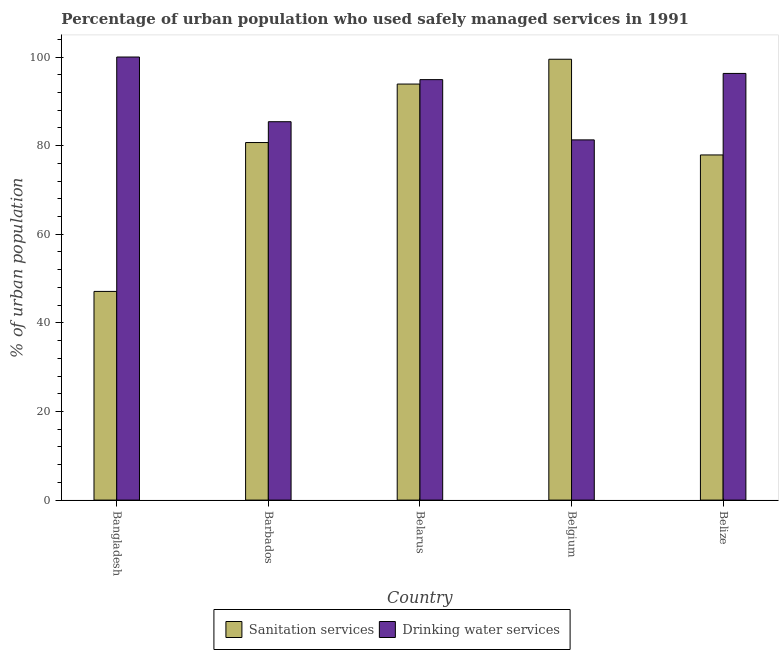How many bars are there on the 4th tick from the right?
Keep it short and to the point. 2. What is the label of the 3rd group of bars from the left?
Provide a succinct answer. Belarus. In how many cases, is the number of bars for a given country not equal to the number of legend labels?
Provide a succinct answer. 0. What is the percentage of urban population who used sanitation services in Belize?
Offer a terse response. 77.9. Across all countries, what is the minimum percentage of urban population who used drinking water services?
Keep it short and to the point. 81.3. In which country was the percentage of urban population who used drinking water services maximum?
Your response must be concise. Bangladesh. In which country was the percentage of urban population who used drinking water services minimum?
Provide a short and direct response. Belgium. What is the total percentage of urban population who used drinking water services in the graph?
Your answer should be compact. 457.9. What is the difference between the percentage of urban population who used sanitation services in Belgium and that in Belize?
Offer a very short reply. 21.6. What is the difference between the percentage of urban population who used drinking water services in Belgium and the percentage of urban population who used sanitation services in Barbados?
Your answer should be compact. 0.6. What is the average percentage of urban population who used drinking water services per country?
Ensure brevity in your answer.  91.58. What is the difference between the percentage of urban population who used sanitation services and percentage of urban population who used drinking water services in Barbados?
Your answer should be compact. -4.7. What is the ratio of the percentage of urban population who used drinking water services in Barbados to that in Belgium?
Your answer should be compact. 1.05. Is the percentage of urban population who used sanitation services in Barbados less than that in Belgium?
Offer a very short reply. Yes. Is the difference between the percentage of urban population who used drinking water services in Bangladesh and Belgium greater than the difference between the percentage of urban population who used sanitation services in Bangladesh and Belgium?
Ensure brevity in your answer.  Yes. What is the difference between the highest and the second highest percentage of urban population who used drinking water services?
Provide a short and direct response. 3.7. What is the difference between the highest and the lowest percentage of urban population who used sanitation services?
Offer a terse response. 52.4. In how many countries, is the percentage of urban population who used sanitation services greater than the average percentage of urban population who used sanitation services taken over all countries?
Give a very brief answer. 3. Is the sum of the percentage of urban population who used drinking water services in Barbados and Belize greater than the maximum percentage of urban population who used sanitation services across all countries?
Give a very brief answer. Yes. What does the 2nd bar from the left in Barbados represents?
Offer a terse response. Drinking water services. What does the 1st bar from the right in Barbados represents?
Your response must be concise. Drinking water services. How many countries are there in the graph?
Your answer should be compact. 5. What is the difference between two consecutive major ticks on the Y-axis?
Your answer should be compact. 20. Are the values on the major ticks of Y-axis written in scientific E-notation?
Provide a short and direct response. No. Where does the legend appear in the graph?
Offer a terse response. Bottom center. How are the legend labels stacked?
Give a very brief answer. Horizontal. What is the title of the graph?
Keep it short and to the point. Percentage of urban population who used safely managed services in 1991. Does "Education" appear as one of the legend labels in the graph?
Provide a short and direct response. No. What is the label or title of the X-axis?
Your answer should be very brief. Country. What is the label or title of the Y-axis?
Make the answer very short. % of urban population. What is the % of urban population in Sanitation services in Bangladesh?
Make the answer very short. 47.1. What is the % of urban population of Drinking water services in Bangladesh?
Your answer should be very brief. 100. What is the % of urban population in Sanitation services in Barbados?
Make the answer very short. 80.7. What is the % of urban population of Drinking water services in Barbados?
Provide a succinct answer. 85.4. What is the % of urban population of Sanitation services in Belarus?
Provide a succinct answer. 93.9. What is the % of urban population in Drinking water services in Belarus?
Keep it short and to the point. 94.9. What is the % of urban population in Sanitation services in Belgium?
Provide a short and direct response. 99.5. What is the % of urban population of Drinking water services in Belgium?
Your response must be concise. 81.3. What is the % of urban population in Sanitation services in Belize?
Ensure brevity in your answer.  77.9. What is the % of urban population of Drinking water services in Belize?
Give a very brief answer. 96.3. Across all countries, what is the maximum % of urban population in Sanitation services?
Give a very brief answer. 99.5. Across all countries, what is the minimum % of urban population in Sanitation services?
Your response must be concise. 47.1. Across all countries, what is the minimum % of urban population in Drinking water services?
Your response must be concise. 81.3. What is the total % of urban population of Sanitation services in the graph?
Your response must be concise. 399.1. What is the total % of urban population of Drinking water services in the graph?
Your response must be concise. 457.9. What is the difference between the % of urban population in Sanitation services in Bangladesh and that in Barbados?
Ensure brevity in your answer.  -33.6. What is the difference between the % of urban population in Sanitation services in Bangladesh and that in Belarus?
Your response must be concise. -46.8. What is the difference between the % of urban population of Drinking water services in Bangladesh and that in Belarus?
Your answer should be compact. 5.1. What is the difference between the % of urban population in Sanitation services in Bangladesh and that in Belgium?
Offer a very short reply. -52.4. What is the difference between the % of urban population of Drinking water services in Bangladesh and that in Belgium?
Your answer should be compact. 18.7. What is the difference between the % of urban population of Sanitation services in Bangladesh and that in Belize?
Your answer should be very brief. -30.8. What is the difference between the % of urban population in Drinking water services in Bangladesh and that in Belize?
Ensure brevity in your answer.  3.7. What is the difference between the % of urban population in Sanitation services in Barbados and that in Belarus?
Offer a very short reply. -13.2. What is the difference between the % of urban population in Drinking water services in Barbados and that in Belarus?
Give a very brief answer. -9.5. What is the difference between the % of urban population in Sanitation services in Barbados and that in Belgium?
Offer a terse response. -18.8. What is the difference between the % of urban population of Drinking water services in Barbados and that in Belgium?
Give a very brief answer. 4.1. What is the difference between the % of urban population of Sanitation services in Barbados and that in Belize?
Your answer should be very brief. 2.8. What is the difference between the % of urban population in Drinking water services in Barbados and that in Belize?
Offer a terse response. -10.9. What is the difference between the % of urban population in Sanitation services in Belarus and that in Belgium?
Your answer should be compact. -5.6. What is the difference between the % of urban population of Drinking water services in Belarus and that in Belgium?
Your answer should be compact. 13.6. What is the difference between the % of urban population of Sanitation services in Belgium and that in Belize?
Provide a short and direct response. 21.6. What is the difference between the % of urban population in Sanitation services in Bangladesh and the % of urban population in Drinking water services in Barbados?
Ensure brevity in your answer.  -38.3. What is the difference between the % of urban population in Sanitation services in Bangladesh and the % of urban population in Drinking water services in Belarus?
Ensure brevity in your answer.  -47.8. What is the difference between the % of urban population of Sanitation services in Bangladesh and the % of urban population of Drinking water services in Belgium?
Provide a succinct answer. -34.2. What is the difference between the % of urban population in Sanitation services in Bangladesh and the % of urban population in Drinking water services in Belize?
Offer a very short reply. -49.2. What is the difference between the % of urban population in Sanitation services in Barbados and the % of urban population in Drinking water services in Belarus?
Your answer should be compact. -14.2. What is the difference between the % of urban population in Sanitation services in Barbados and the % of urban population in Drinking water services in Belgium?
Provide a succinct answer. -0.6. What is the difference between the % of urban population in Sanitation services in Barbados and the % of urban population in Drinking water services in Belize?
Provide a succinct answer. -15.6. What is the difference between the % of urban population in Sanitation services in Belarus and the % of urban population in Drinking water services in Belize?
Make the answer very short. -2.4. What is the difference between the % of urban population in Sanitation services in Belgium and the % of urban population in Drinking water services in Belize?
Offer a terse response. 3.2. What is the average % of urban population in Sanitation services per country?
Keep it short and to the point. 79.82. What is the average % of urban population in Drinking water services per country?
Give a very brief answer. 91.58. What is the difference between the % of urban population in Sanitation services and % of urban population in Drinking water services in Bangladesh?
Give a very brief answer. -52.9. What is the difference between the % of urban population in Sanitation services and % of urban population in Drinking water services in Barbados?
Offer a very short reply. -4.7. What is the difference between the % of urban population of Sanitation services and % of urban population of Drinking water services in Belarus?
Your answer should be compact. -1. What is the difference between the % of urban population in Sanitation services and % of urban population in Drinking water services in Belgium?
Provide a succinct answer. 18.2. What is the difference between the % of urban population in Sanitation services and % of urban population in Drinking water services in Belize?
Ensure brevity in your answer.  -18.4. What is the ratio of the % of urban population of Sanitation services in Bangladesh to that in Barbados?
Make the answer very short. 0.58. What is the ratio of the % of urban population in Drinking water services in Bangladesh to that in Barbados?
Ensure brevity in your answer.  1.17. What is the ratio of the % of urban population in Sanitation services in Bangladesh to that in Belarus?
Your answer should be compact. 0.5. What is the ratio of the % of urban population of Drinking water services in Bangladesh to that in Belarus?
Give a very brief answer. 1.05. What is the ratio of the % of urban population in Sanitation services in Bangladesh to that in Belgium?
Provide a short and direct response. 0.47. What is the ratio of the % of urban population in Drinking water services in Bangladesh to that in Belgium?
Give a very brief answer. 1.23. What is the ratio of the % of urban population in Sanitation services in Bangladesh to that in Belize?
Keep it short and to the point. 0.6. What is the ratio of the % of urban population of Drinking water services in Bangladesh to that in Belize?
Ensure brevity in your answer.  1.04. What is the ratio of the % of urban population in Sanitation services in Barbados to that in Belarus?
Make the answer very short. 0.86. What is the ratio of the % of urban population of Drinking water services in Barbados to that in Belarus?
Make the answer very short. 0.9. What is the ratio of the % of urban population in Sanitation services in Barbados to that in Belgium?
Offer a terse response. 0.81. What is the ratio of the % of urban population in Drinking water services in Barbados to that in Belgium?
Provide a short and direct response. 1.05. What is the ratio of the % of urban population in Sanitation services in Barbados to that in Belize?
Offer a terse response. 1.04. What is the ratio of the % of urban population in Drinking water services in Barbados to that in Belize?
Keep it short and to the point. 0.89. What is the ratio of the % of urban population in Sanitation services in Belarus to that in Belgium?
Keep it short and to the point. 0.94. What is the ratio of the % of urban population in Drinking water services in Belarus to that in Belgium?
Ensure brevity in your answer.  1.17. What is the ratio of the % of urban population of Sanitation services in Belarus to that in Belize?
Keep it short and to the point. 1.21. What is the ratio of the % of urban population in Drinking water services in Belarus to that in Belize?
Give a very brief answer. 0.99. What is the ratio of the % of urban population in Sanitation services in Belgium to that in Belize?
Give a very brief answer. 1.28. What is the ratio of the % of urban population in Drinking water services in Belgium to that in Belize?
Offer a very short reply. 0.84. What is the difference between the highest and the second highest % of urban population of Sanitation services?
Offer a very short reply. 5.6. What is the difference between the highest and the lowest % of urban population in Sanitation services?
Keep it short and to the point. 52.4. 